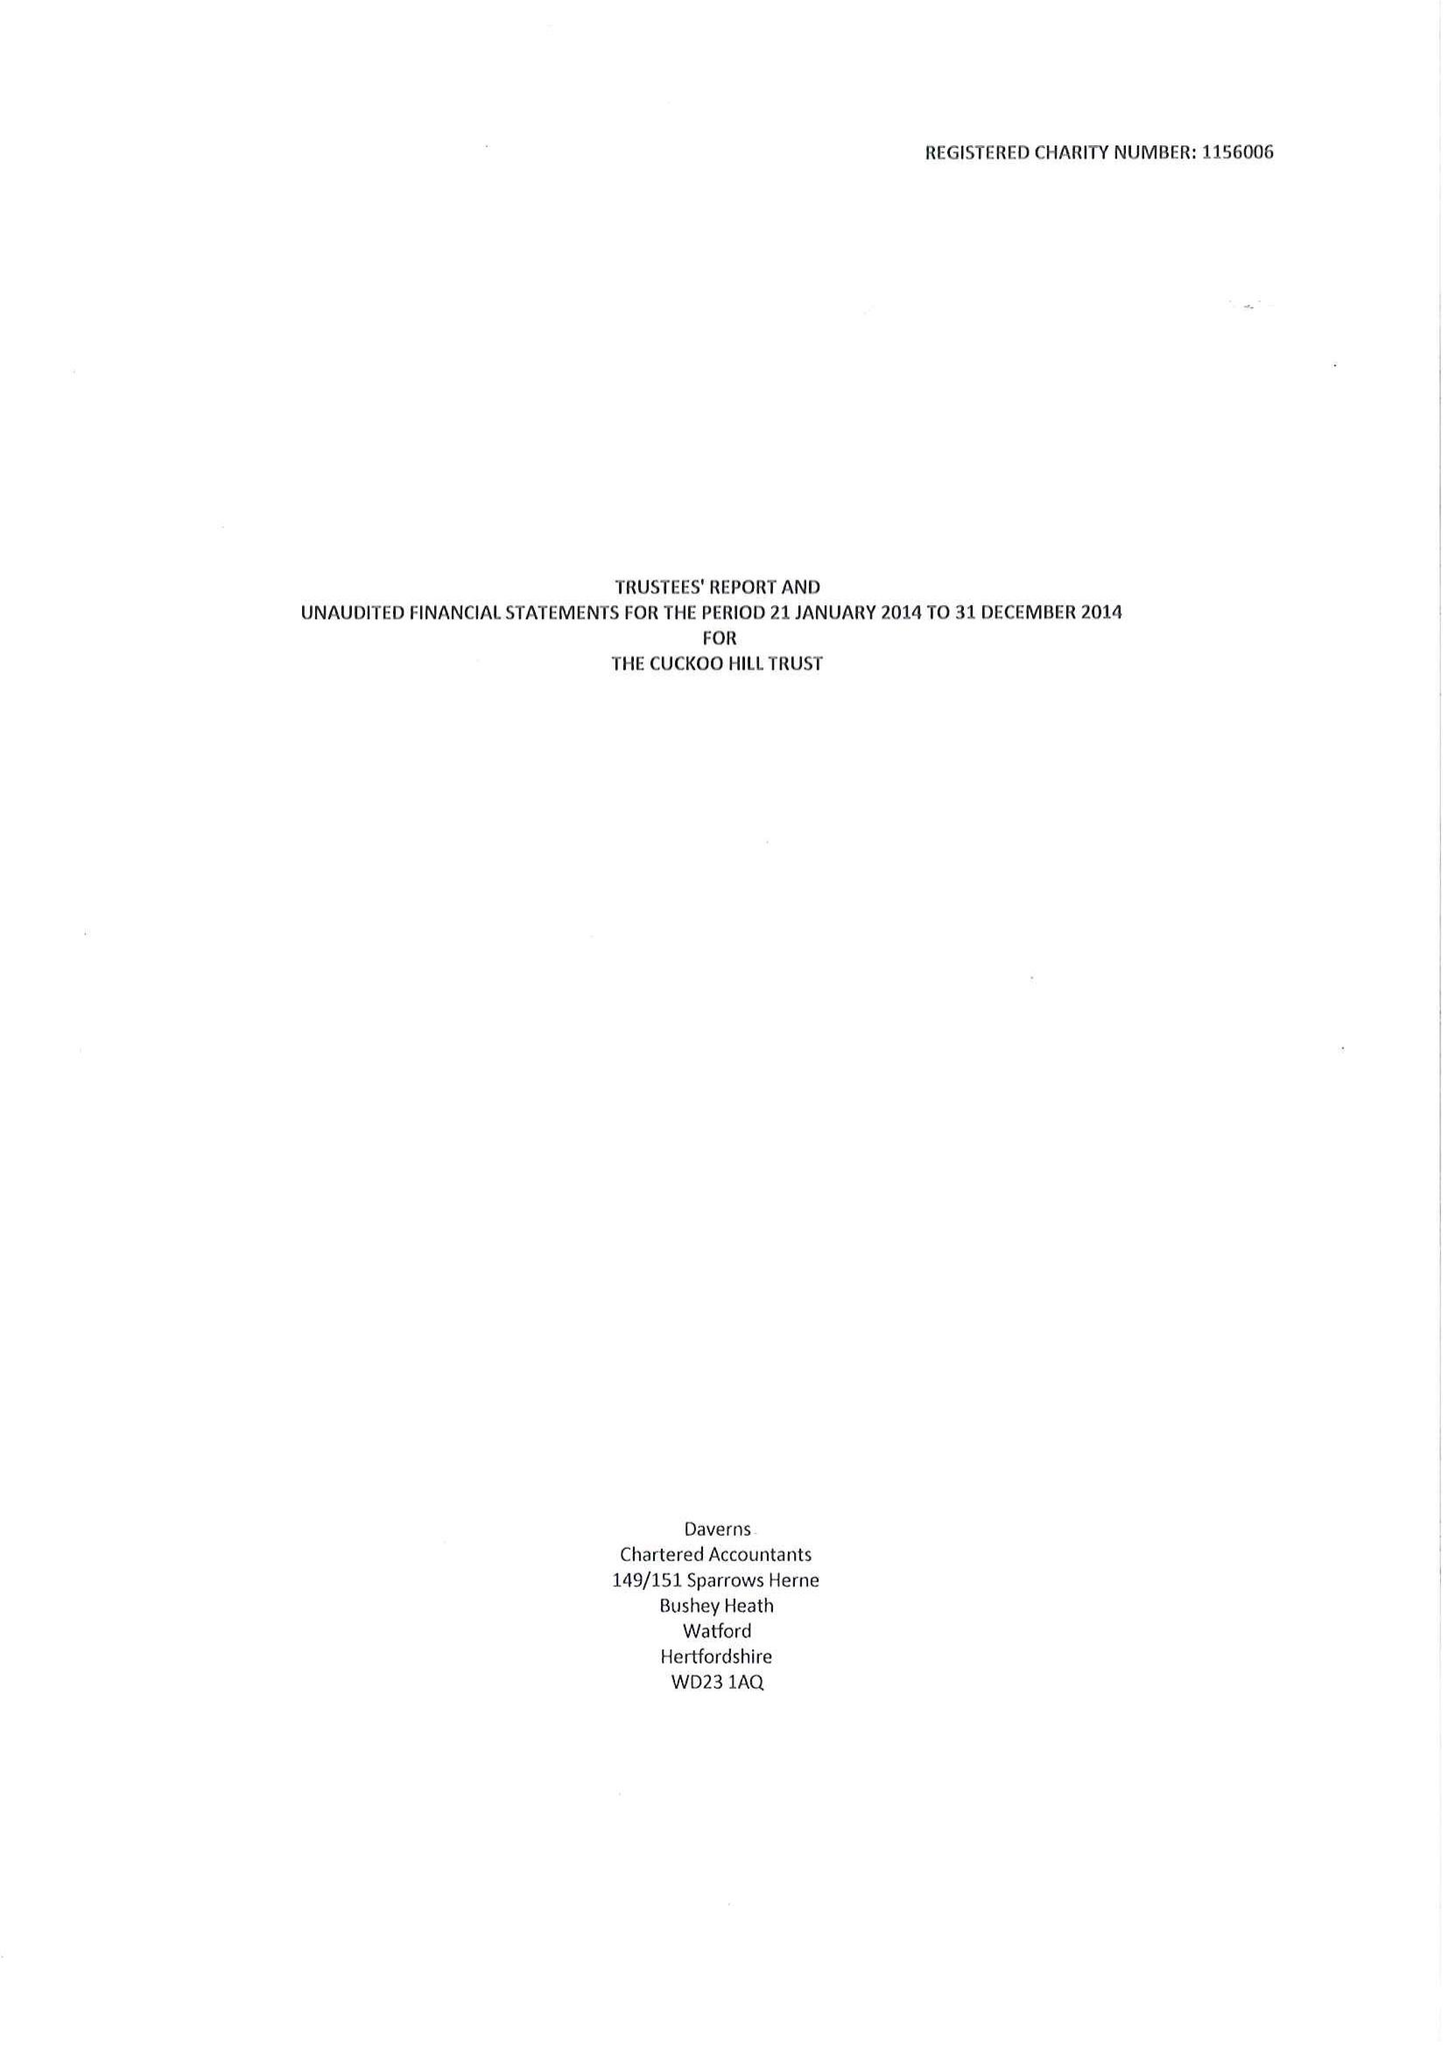What is the value for the income_annually_in_british_pounds?
Answer the question using a single word or phrase. 94750.00 